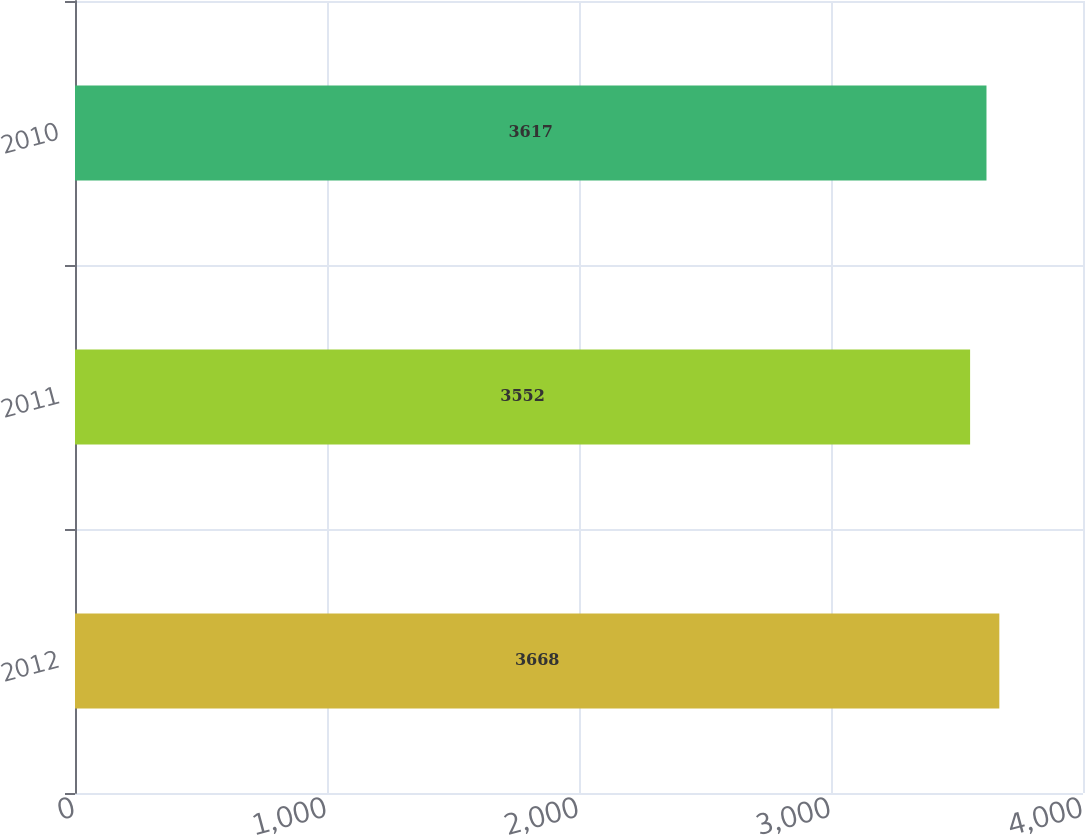Convert chart. <chart><loc_0><loc_0><loc_500><loc_500><bar_chart><fcel>2012<fcel>2011<fcel>2010<nl><fcel>3668<fcel>3552<fcel>3617<nl></chart> 